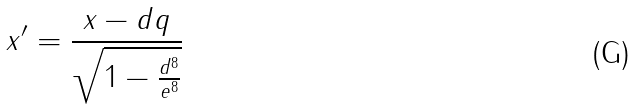<formula> <loc_0><loc_0><loc_500><loc_500>x ^ { \prime } = \frac { x - d q } { \sqrt { 1 - \frac { d ^ { 8 } } { e ^ { 8 } } } }</formula> 